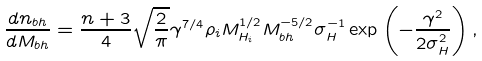Convert formula to latex. <formula><loc_0><loc_0><loc_500><loc_500>\frac { d n _ { b h } } { d M _ { b h } } = \frac { n + 3 } { 4 } \sqrt { \frac { 2 } { \pi } } \gamma ^ { 7 / 4 } \rho _ { i } M ^ { 1 / 2 } _ { H _ { i } } M _ { b h } ^ { - 5 / 2 } \sigma _ { H } ^ { - 1 } \exp \left ( - \frac { \gamma ^ { 2 } } { 2 \sigma _ { H } ^ { 2 } } \right ) ,</formula> 